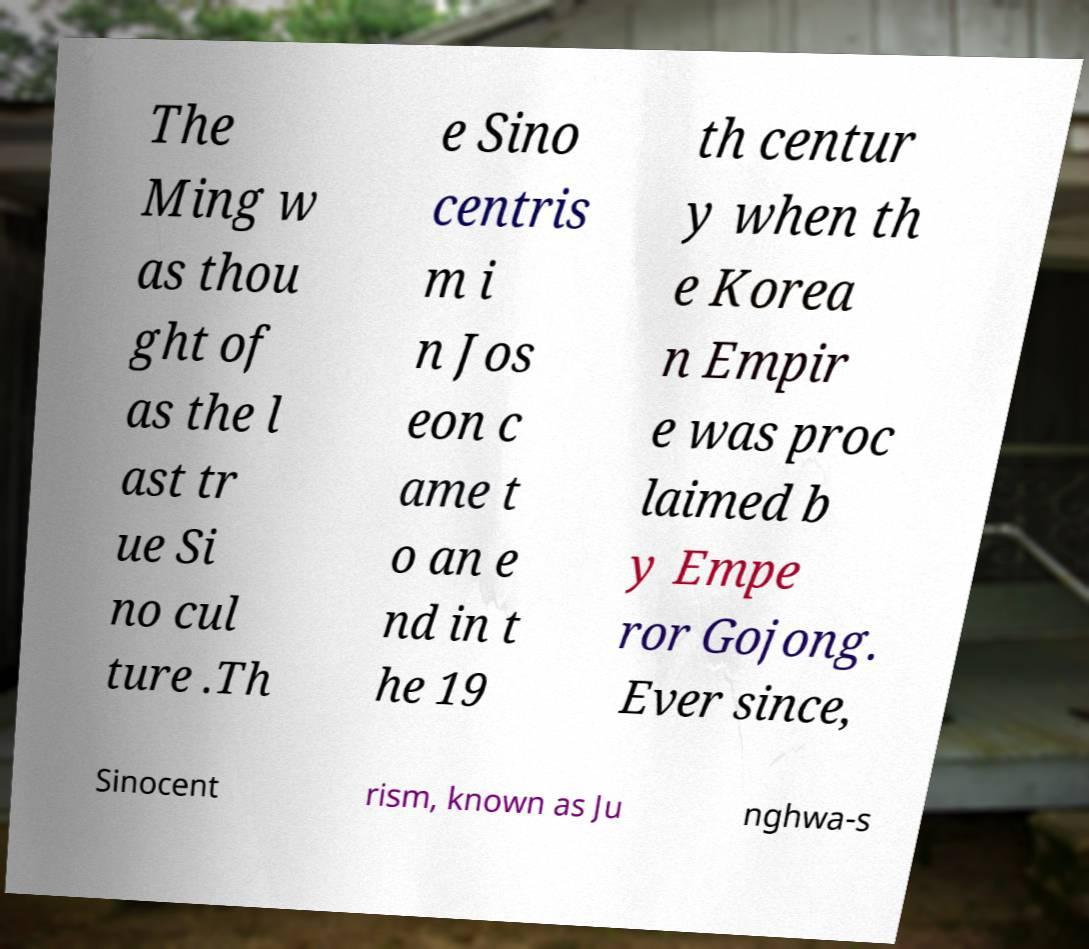Please read and relay the text visible in this image. What does it say? The Ming w as thou ght of as the l ast tr ue Si no cul ture .Th e Sino centris m i n Jos eon c ame t o an e nd in t he 19 th centur y when th e Korea n Empir e was proc laimed b y Empe ror Gojong. Ever since, Sinocent rism, known as Ju nghwa-s 